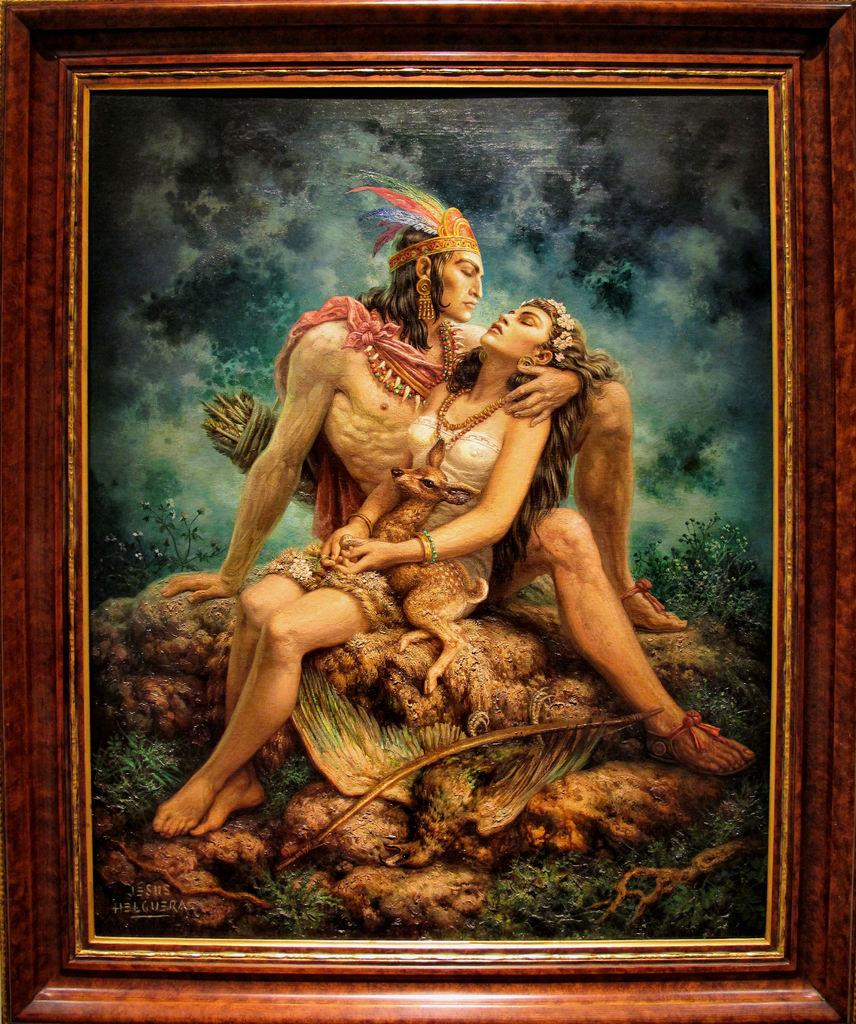What is the main object in the image? There is a photo with a frame in the image. Who or what is depicted in the photo? The photo contains two persons and a deer. Is there any text on the photo? Yes, there is writing on the photo. What is the reaction of the things in the image when they see the deer? There are no "things" present in the image, and therefore no reaction can be observed. 